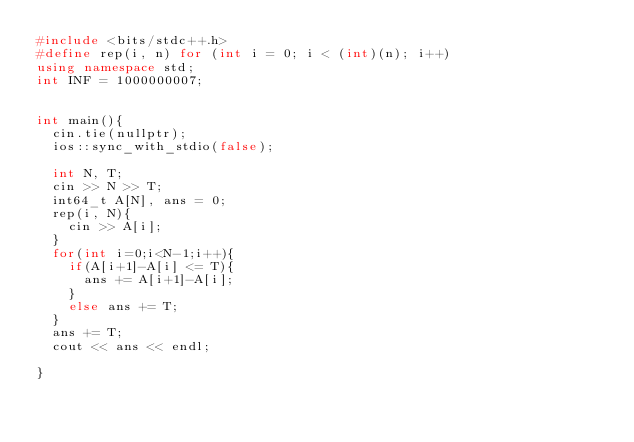<code> <loc_0><loc_0><loc_500><loc_500><_C++_>#include <bits/stdc++.h>
#define rep(i, n) for (int i = 0; i < (int)(n); i++)
using namespace std;
int INF = 1000000007;
 
 
int main(){
  cin.tie(nullptr);
  ios::sync_with_stdio(false);
 
  int N, T;
  cin >> N >> T;
  int64_t A[N], ans = 0;
  rep(i, N){
    cin >> A[i];
  }
  for(int i=0;i<N-1;i++){
    if(A[i+1]-A[i] <= T){
      ans += A[i+1]-A[i];
    }
    else ans += T;
  }
  ans += T;
  cout << ans << endl;
 
}</code> 